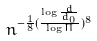Convert formula to latex. <formula><loc_0><loc_0><loc_500><loc_500>n ^ { - \frac { 1 } { 8 } ( \frac { \log \frac { d } { d _ { 0 } } } { \log \Pi } ) ^ { 8 } }</formula> 